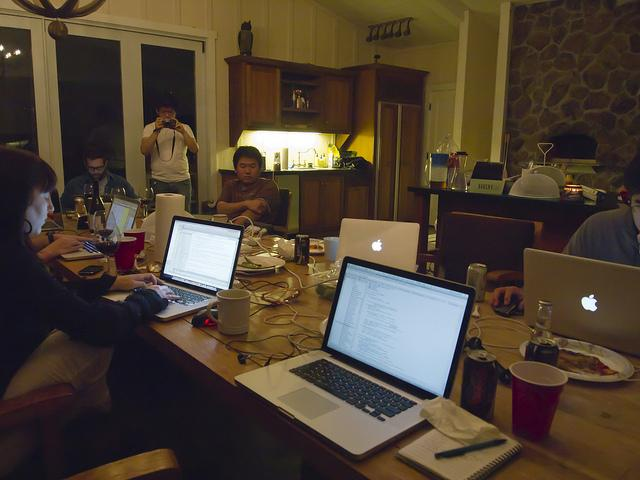What type of animal can be seen on top of the shelf near the back doors? Please explain your reasoning. owl. It has that round head with wings held against its body on the sides and looks like a vase. 